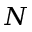Convert formula to latex. <formula><loc_0><loc_0><loc_500><loc_500>N</formula> 